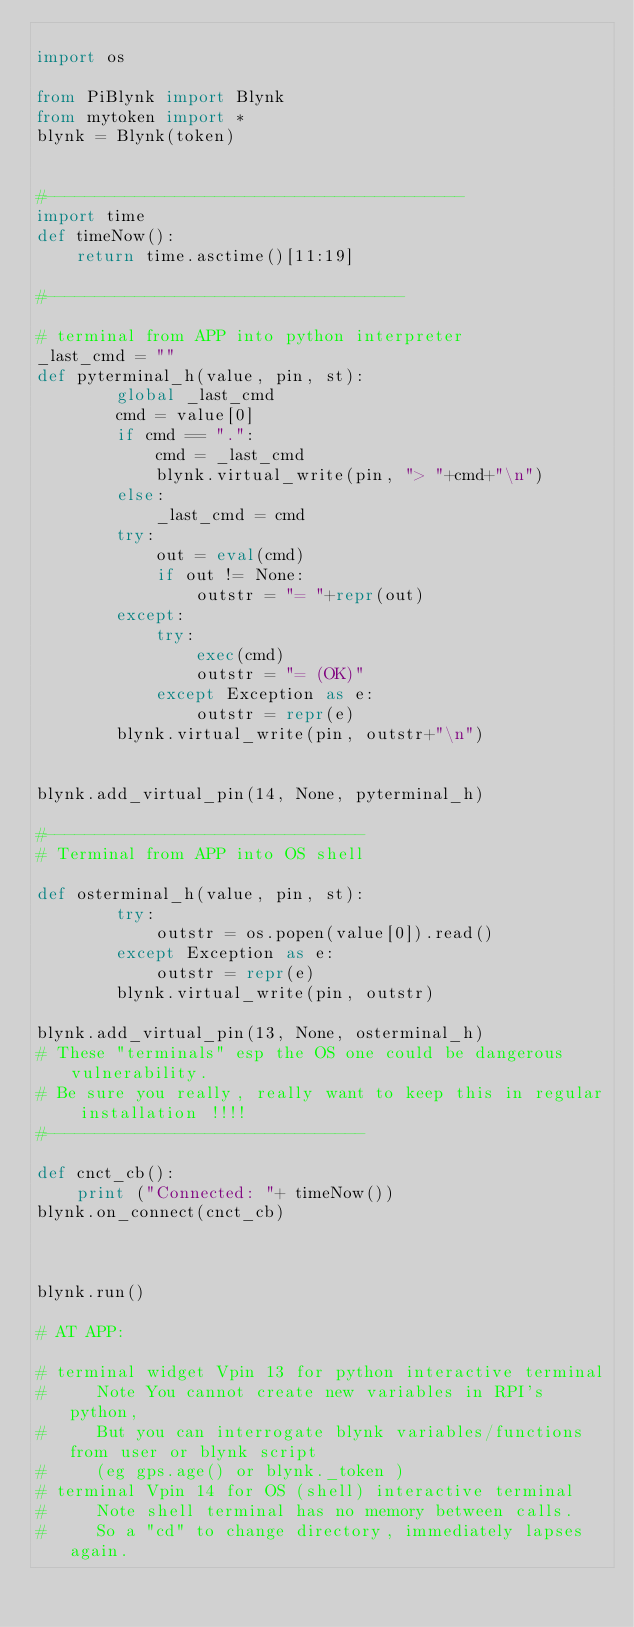<code> <loc_0><loc_0><loc_500><loc_500><_Python_>
import os

from PiBlynk import Blynk
from mytoken import *
blynk = Blynk(token)


#------------------------------------------
import time
def timeNow():
    return time.asctime()[11:19]

#------------------------------------

# terminal from APP into python interpreter
_last_cmd = ""
def pyterminal_h(value, pin, st):
        global _last_cmd
        cmd = value[0]
        if cmd == ".":
            cmd = _last_cmd
            blynk.virtual_write(pin, "> "+cmd+"\n")
        else:
            _last_cmd = cmd
        try:
            out = eval(cmd)
            if out != None:
                outstr = "= "+repr(out)
        except:
            try:
                exec(cmd)
                outstr = "= (OK)"
            except Exception as e:
                outstr = repr(e)
        blynk.virtual_write(pin, outstr+"\n")
        

blynk.add_virtual_pin(14, None, pyterminal_h)

#--------------------------------
# Terminal from APP into OS shell

def osterminal_h(value, pin, st):
        try:
            outstr = os.popen(value[0]).read()
        except Exception as e:
            outstr = repr(e)
        blynk.virtual_write(pin, outstr)

blynk.add_virtual_pin(13, None, osterminal_h)
# These "terminals" esp the OS one could be dangerous vulnerability. 
# Be sure you really, really want to keep this in regular installation !!!!
#--------------------------------

def cnct_cb():
    print ("Connected: "+ timeNow())
blynk.on_connect(cnct_cb)



blynk.run()

# AT APP:

# terminal widget Vpin 13 for python interactive terminal 
#     Note You cannot create new variables in RPI's python,
#     But you can interrogate blynk variables/functions from user or blynk script 
#     (eg gps.age() or blynk._token )
# terminal Vpin 14 for OS (shell) interactive terminal
#     Note shell terminal has no memory between calls. 
#     So a "cd" to change directory, immediately lapses again.

</code> 